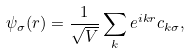<formula> <loc_0><loc_0><loc_500><loc_500>\psi _ { \sigma } ( { r } ) = \frac { 1 } { \sqrt { V } } \sum _ { k } e ^ { i { k r } } c _ { { k } \sigma } ,</formula> 